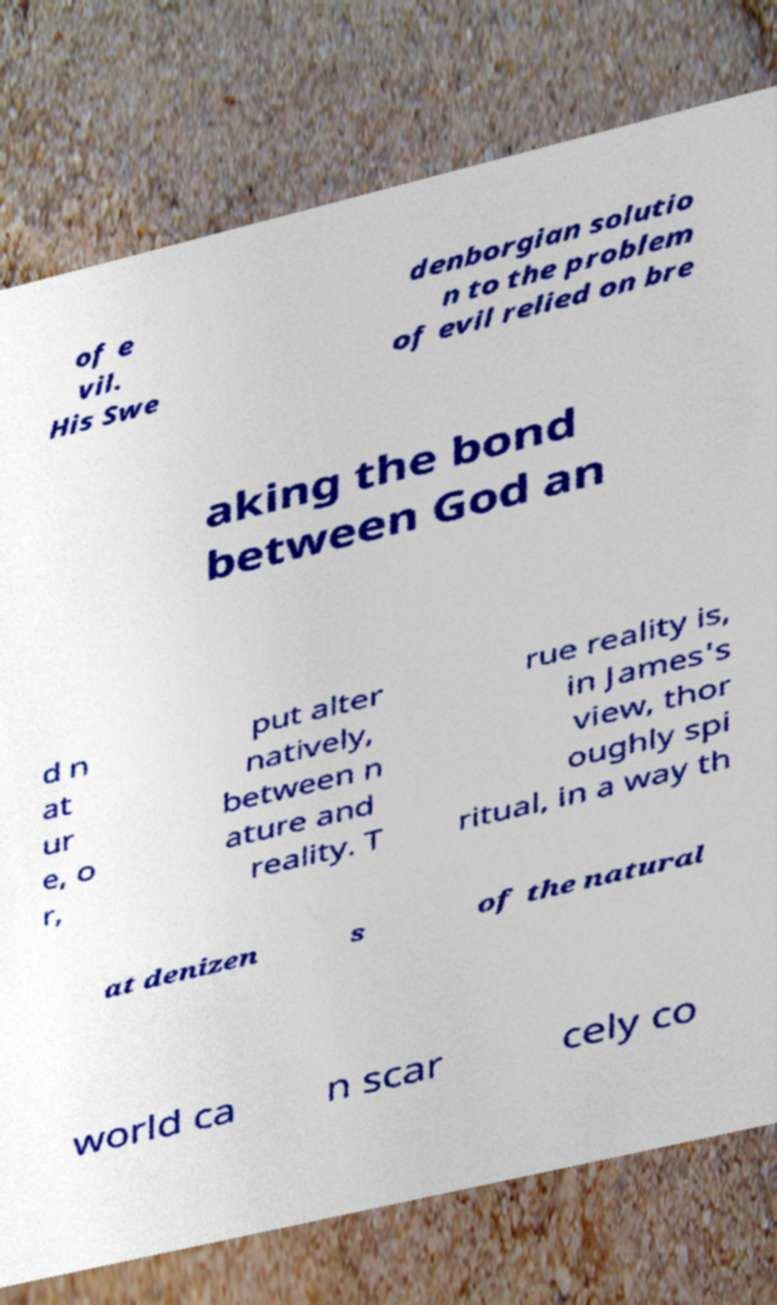Can you accurately transcribe the text from the provided image for me? of e vil. His Swe denborgian solutio n to the problem of evil relied on bre aking the bond between God an d n at ur e, o r, put alter natively, between n ature and reality. T rue reality is, in James's view, thor oughly spi ritual, in a way th at denizen s of the natural world ca n scar cely co 